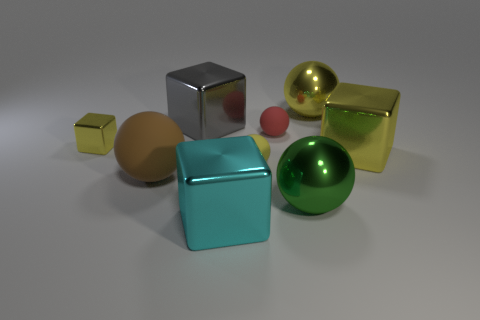Subtract all green balls. How many balls are left? 4 Subtract all brown balls. How many balls are left? 4 Subtract all blue balls. Subtract all purple blocks. How many balls are left? 5 Subtract all cubes. How many objects are left? 5 Subtract 2 yellow cubes. How many objects are left? 7 Subtract all small gray things. Subtract all big shiny balls. How many objects are left? 7 Add 3 small red objects. How many small red objects are left? 4 Add 3 big gray shiny objects. How many big gray shiny objects exist? 4 